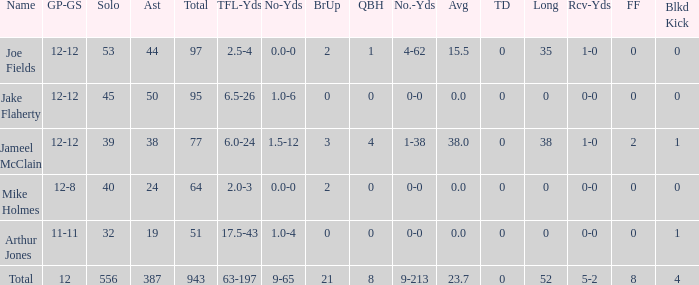What is the largest number of tds scored for a player? 0.0. 